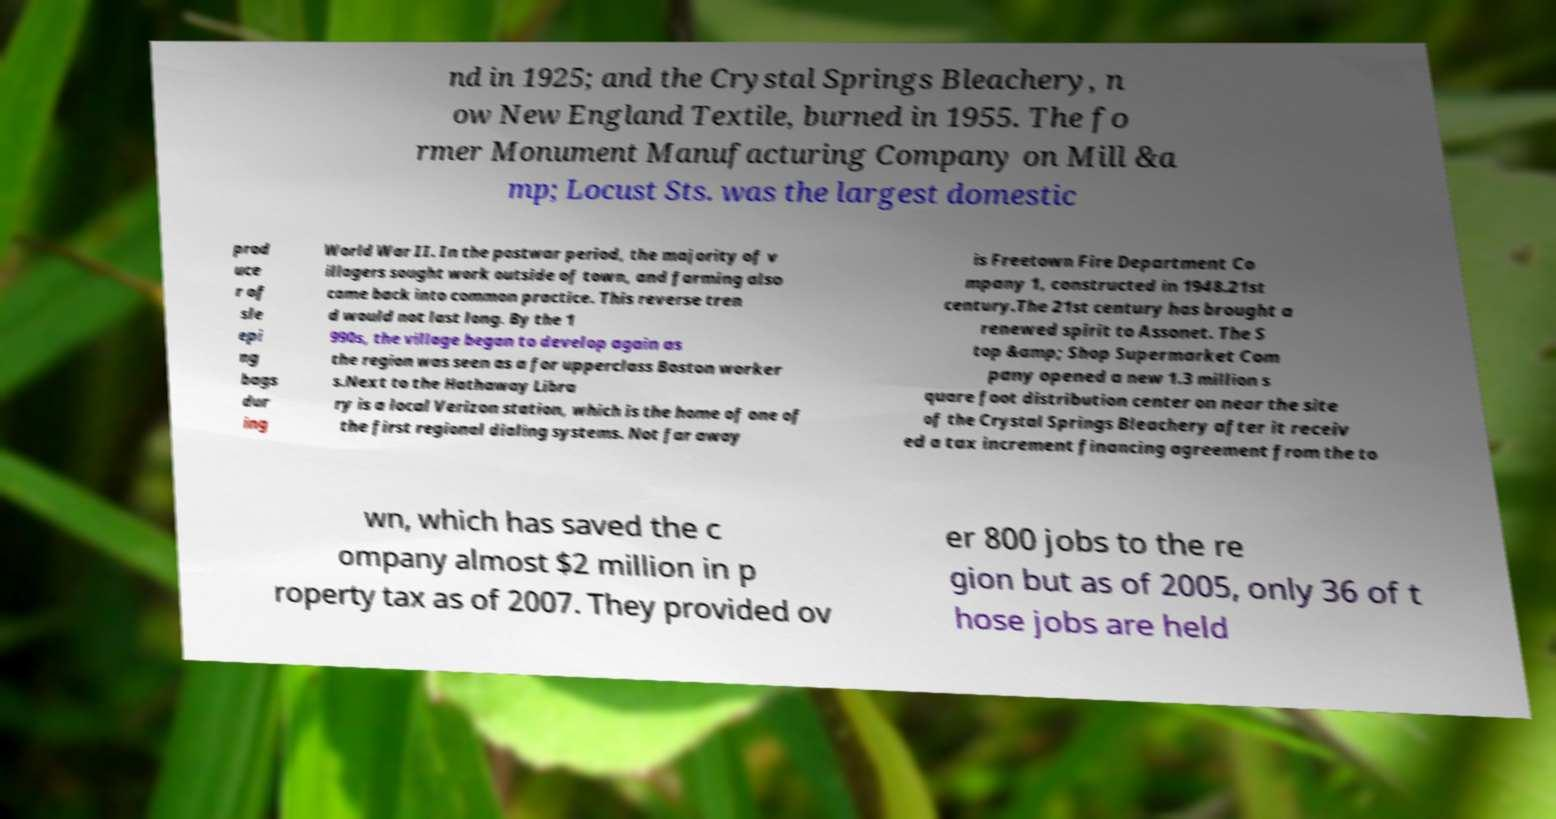Please identify and transcribe the text found in this image. nd in 1925; and the Crystal Springs Bleachery, n ow New England Textile, burned in 1955. The fo rmer Monument Manufacturing Company on Mill &a mp; Locust Sts. was the largest domestic prod uce r of sle epi ng bags dur ing World War II. In the postwar period, the majority of v illagers sought work outside of town, and farming also came back into common practice. This reverse tren d would not last long. By the 1 990s, the village began to develop again as the region was seen as a for upperclass Boston worker s.Next to the Hathaway Libra ry is a local Verizon station, which is the home of one of the first regional dialing systems. Not far away is Freetown Fire Department Co mpany 1, constructed in 1948.21st century.The 21st century has brought a renewed spirit to Assonet. The S top &amp; Shop Supermarket Com pany opened a new 1.3 million s quare foot distribution center on near the site of the Crystal Springs Bleachery after it receiv ed a tax increment financing agreement from the to wn, which has saved the c ompany almost $2 million in p roperty tax as of 2007. They provided ov er 800 jobs to the re gion but as of 2005, only 36 of t hose jobs are held 